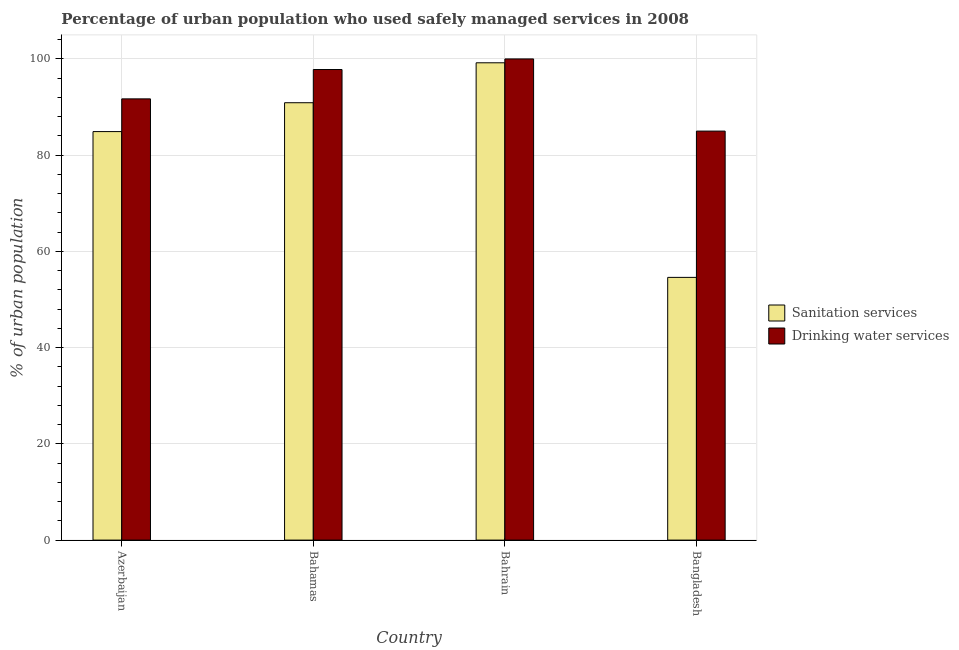How many different coloured bars are there?
Your response must be concise. 2. How many groups of bars are there?
Offer a terse response. 4. Are the number of bars per tick equal to the number of legend labels?
Your answer should be very brief. Yes. How many bars are there on the 2nd tick from the right?
Provide a succinct answer. 2. What is the label of the 3rd group of bars from the left?
Give a very brief answer. Bahrain. What is the percentage of urban population who used drinking water services in Azerbaijan?
Your answer should be very brief. 91.7. Across all countries, what is the maximum percentage of urban population who used drinking water services?
Keep it short and to the point. 100. Across all countries, what is the minimum percentage of urban population who used sanitation services?
Offer a very short reply. 54.6. In which country was the percentage of urban population who used drinking water services maximum?
Make the answer very short. Bahrain. What is the total percentage of urban population who used drinking water services in the graph?
Provide a succinct answer. 374.5. What is the difference between the percentage of urban population who used drinking water services in Azerbaijan and that in Bangladesh?
Offer a very short reply. 6.7. What is the difference between the percentage of urban population who used sanitation services in Bangladesh and the percentage of urban population who used drinking water services in Azerbaijan?
Ensure brevity in your answer.  -37.1. What is the average percentage of urban population who used sanitation services per country?
Provide a short and direct response. 82.4. What is the difference between the percentage of urban population who used sanitation services and percentage of urban population who used drinking water services in Bahamas?
Ensure brevity in your answer.  -6.9. What is the ratio of the percentage of urban population who used drinking water services in Azerbaijan to that in Bangladesh?
Your response must be concise. 1.08. What is the difference between the highest and the second highest percentage of urban population who used drinking water services?
Offer a terse response. 2.2. Is the sum of the percentage of urban population who used drinking water services in Bahrain and Bangladesh greater than the maximum percentage of urban population who used sanitation services across all countries?
Give a very brief answer. Yes. What does the 1st bar from the left in Bangladesh represents?
Your answer should be compact. Sanitation services. What does the 2nd bar from the right in Bahamas represents?
Make the answer very short. Sanitation services. How many bars are there?
Provide a succinct answer. 8. Are all the bars in the graph horizontal?
Provide a succinct answer. No. How many countries are there in the graph?
Keep it short and to the point. 4. What is the difference between two consecutive major ticks on the Y-axis?
Your answer should be compact. 20. Does the graph contain any zero values?
Keep it short and to the point. No. Where does the legend appear in the graph?
Make the answer very short. Center right. How many legend labels are there?
Keep it short and to the point. 2. How are the legend labels stacked?
Keep it short and to the point. Vertical. What is the title of the graph?
Your answer should be very brief. Percentage of urban population who used safely managed services in 2008. What is the label or title of the X-axis?
Give a very brief answer. Country. What is the label or title of the Y-axis?
Offer a very short reply. % of urban population. What is the % of urban population in Sanitation services in Azerbaijan?
Your response must be concise. 84.9. What is the % of urban population in Drinking water services in Azerbaijan?
Your answer should be very brief. 91.7. What is the % of urban population of Sanitation services in Bahamas?
Your answer should be compact. 90.9. What is the % of urban population of Drinking water services in Bahamas?
Keep it short and to the point. 97.8. What is the % of urban population in Sanitation services in Bahrain?
Offer a very short reply. 99.2. What is the % of urban population of Sanitation services in Bangladesh?
Make the answer very short. 54.6. What is the % of urban population of Drinking water services in Bangladesh?
Your answer should be very brief. 85. Across all countries, what is the maximum % of urban population in Sanitation services?
Provide a short and direct response. 99.2. Across all countries, what is the maximum % of urban population in Drinking water services?
Keep it short and to the point. 100. Across all countries, what is the minimum % of urban population in Sanitation services?
Offer a very short reply. 54.6. What is the total % of urban population in Sanitation services in the graph?
Offer a very short reply. 329.6. What is the total % of urban population in Drinking water services in the graph?
Provide a succinct answer. 374.5. What is the difference between the % of urban population in Sanitation services in Azerbaijan and that in Bahrain?
Make the answer very short. -14.3. What is the difference between the % of urban population in Sanitation services in Azerbaijan and that in Bangladesh?
Offer a terse response. 30.3. What is the difference between the % of urban population of Drinking water services in Azerbaijan and that in Bangladesh?
Keep it short and to the point. 6.7. What is the difference between the % of urban population in Sanitation services in Bahamas and that in Bahrain?
Provide a succinct answer. -8.3. What is the difference between the % of urban population in Sanitation services in Bahamas and that in Bangladesh?
Your response must be concise. 36.3. What is the difference between the % of urban population of Drinking water services in Bahamas and that in Bangladesh?
Offer a very short reply. 12.8. What is the difference between the % of urban population of Sanitation services in Bahrain and that in Bangladesh?
Your response must be concise. 44.6. What is the difference between the % of urban population of Drinking water services in Bahrain and that in Bangladesh?
Keep it short and to the point. 15. What is the difference between the % of urban population of Sanitation services in Azerbaijan and the % of urban population of Drinking water services in Bahrain?
Provide a succinct answer. -15.1. What is the difference between the % of urban population in Sanitation services in Bahamas and the % of urban population in Drinking water services in Bahrain?
Provide a succinct answer. -9.1. What is the average % of urban population of Sanitation services per country?
Provide a short and direct response. 82.4. What is the average % of urban population in Drinking water services per country?
Offer a very short reply. 93.62. What is the difference between the % of urban population of Sanitation services and % of urban population of Drinking water services in Bahamas?
Offer a very short reply. -6.9. What is the difference between the % of urban population in Sanitation services and % of urban population in Drinking water services in Bahrain?
Your response must be concise. -0.8. What is the difference between the % of urban population in Sanitation services and % of urban population in Drinking water services in Bangladesh?
Your answer should be compact. -30.4. What is the ratio of the % of urban population of Sanitation services in Azerbaijan to that in Bahamas?
Provide a short and direct response. 0.93. What is the ratio of the % of urban population in Drinking water services in Azerbaijan to that in Bahamas?
Your response must be concise. 0.94. What is the ratio of the % of urban population of Sanitation services in Azerbaijan to that in Bahrain?
Provide a short and direct response. 0.86. What is the ratio of the % of urban population in Drinking water services in Azerbaijan to that in Bahrain?
Provide a short and direct response. 0.92. What is the ratio of the % of urban population of Sanitation services in Azerbaijan to that in Bangladesh?
Your answer should be compact. 1.55. What is the ratio of the % of urban population in Drinking water services in Azerbaijan to that in Bangladesh?
Offer a terse response. 1.08. What is the ratio of the % of urban population in Sanitation services in Bahamas to that in Bahrain?
Offer a terse response. 0.92. What is the ratio of the % of urban population in Drinking water services in Bahamas to that in Bahrain?
Your response must be concise. 0.98. What is the ratio of the % of urban population of Sanitation services in Bahamas to that in Bangladesh?
Your answer should be compact. 1.66. What is the ratio of the % of urban population of Drinking water services in Bahamas to that in Bangladesh?
Ensure brevity in your answer.  1.15. What is the ratio of the % of urban population in Sanitation services in Bahrain to that in Bangladesh?
Your answer should be very brief. 1.82. What is the ratio of the % of urban population of Drinking water services in Bahrain to that in Bangladesh?
Make the answer very short. 1.18. What is the difference between the highest and the lowest % of urban population of Sanitation services?
Offer a very short reply. 44.6. 